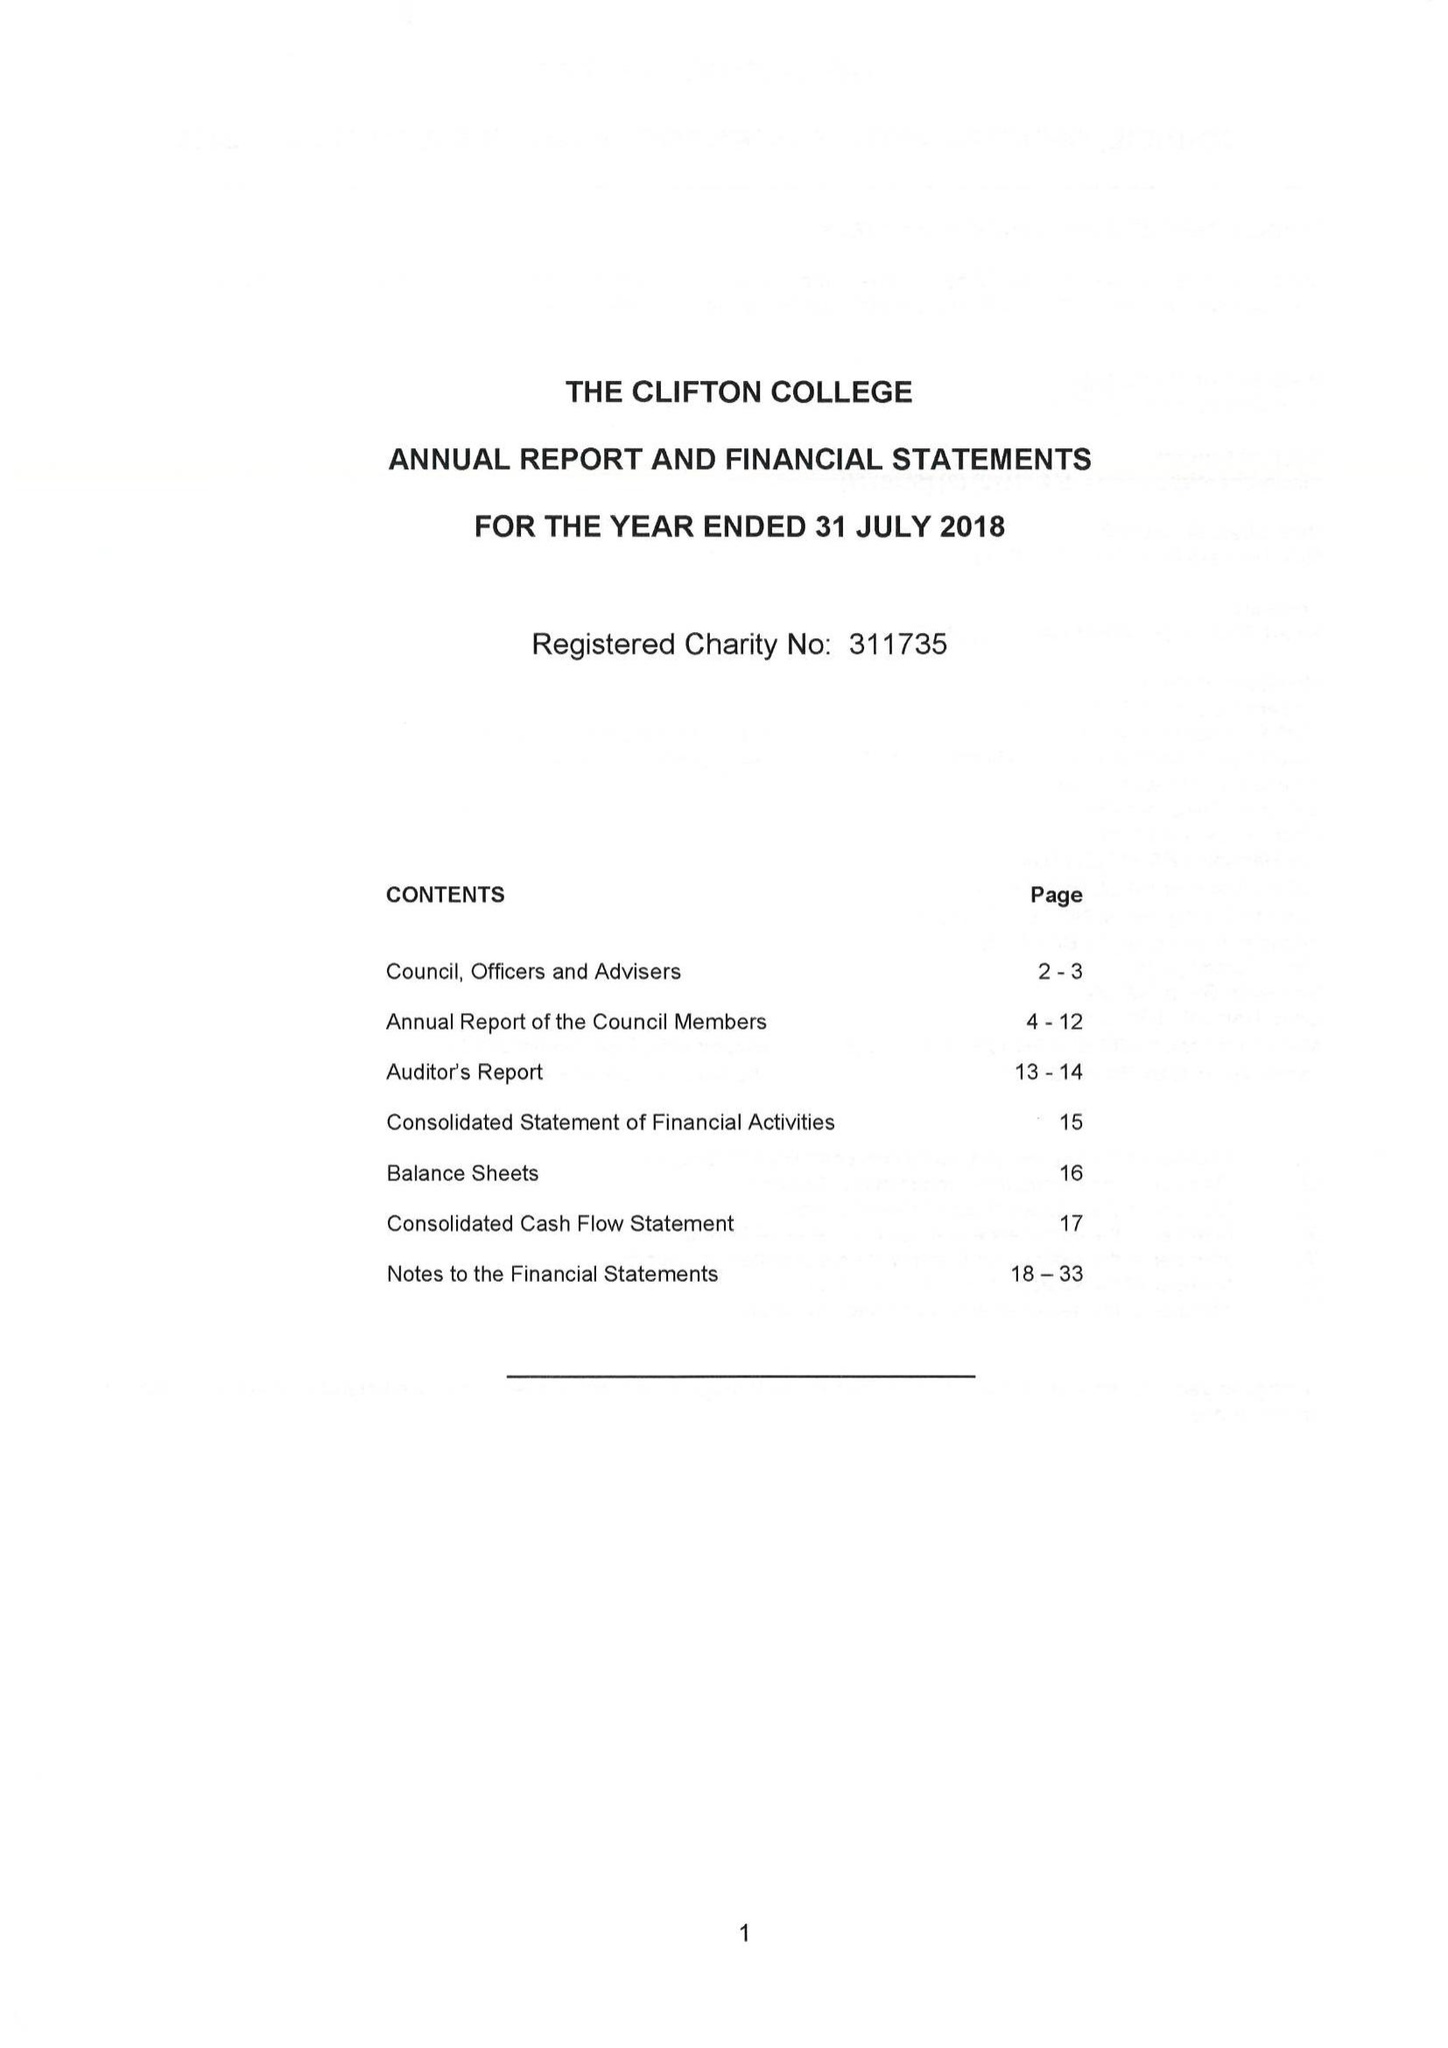What is the value for the address__street_line?
Answer the question using a single word or phrase. 32 COLLEGE ROAD 